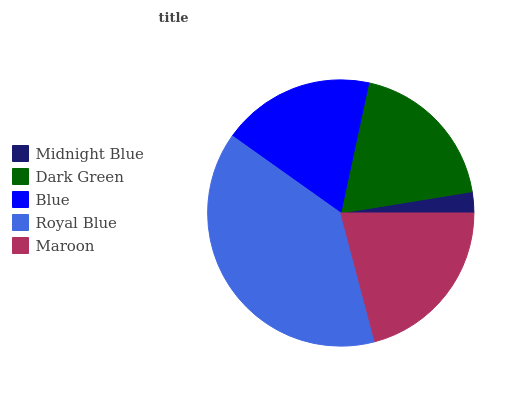Is Midnight Blue the minimum?
Answer yes or no. Yes. Is Royal Blue the maximum?
Answer yes or no. Yes. Is Dark Green the minimum?
Answer yes or no. No. Is Dark Green the maximum?
Answer yes or no. No. Is Dark Green greater than Midnight Blue?
Answer yes or no. Yes. Is Midnight Blue less than Dark Green?
Answer yes or no. Yes. Is Midnight Blue greater than Dark Green?
Answer yes or no. No. Is Dark Green less than Midnight Blue?
Answer yes or no. No. Is Dark Green the high median?
Answer yes or no. Yes. Is Dark Green the low median?
Answer yes or no. Yes. Is Royal Blue the high median?
Answer yes or no. No. Is Maroon the low median?
Answer yes or no. No. 